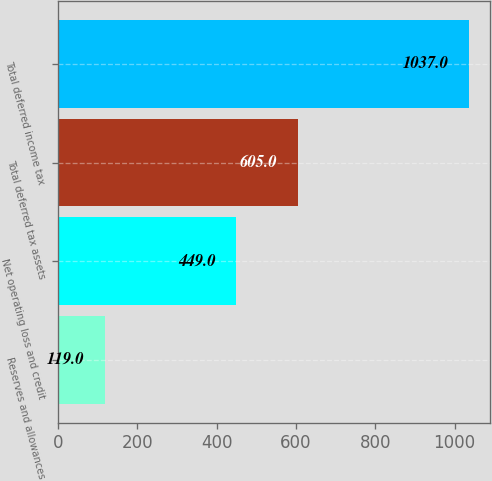<chart> <loc_0><loc_0><loc_500><loc_500><bar_chart><fcel>Reserves and allowances<fcel>Net operating loss and credit<fcel>Total deferred tax assets<fcel>Total deferred income tax<nl><fcel>119<fcel>449<fcel>605<fcel>1037<nl></chart> 